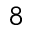<formula> <loc_0><loc_0><loc_500><loc_500>8</formula> 